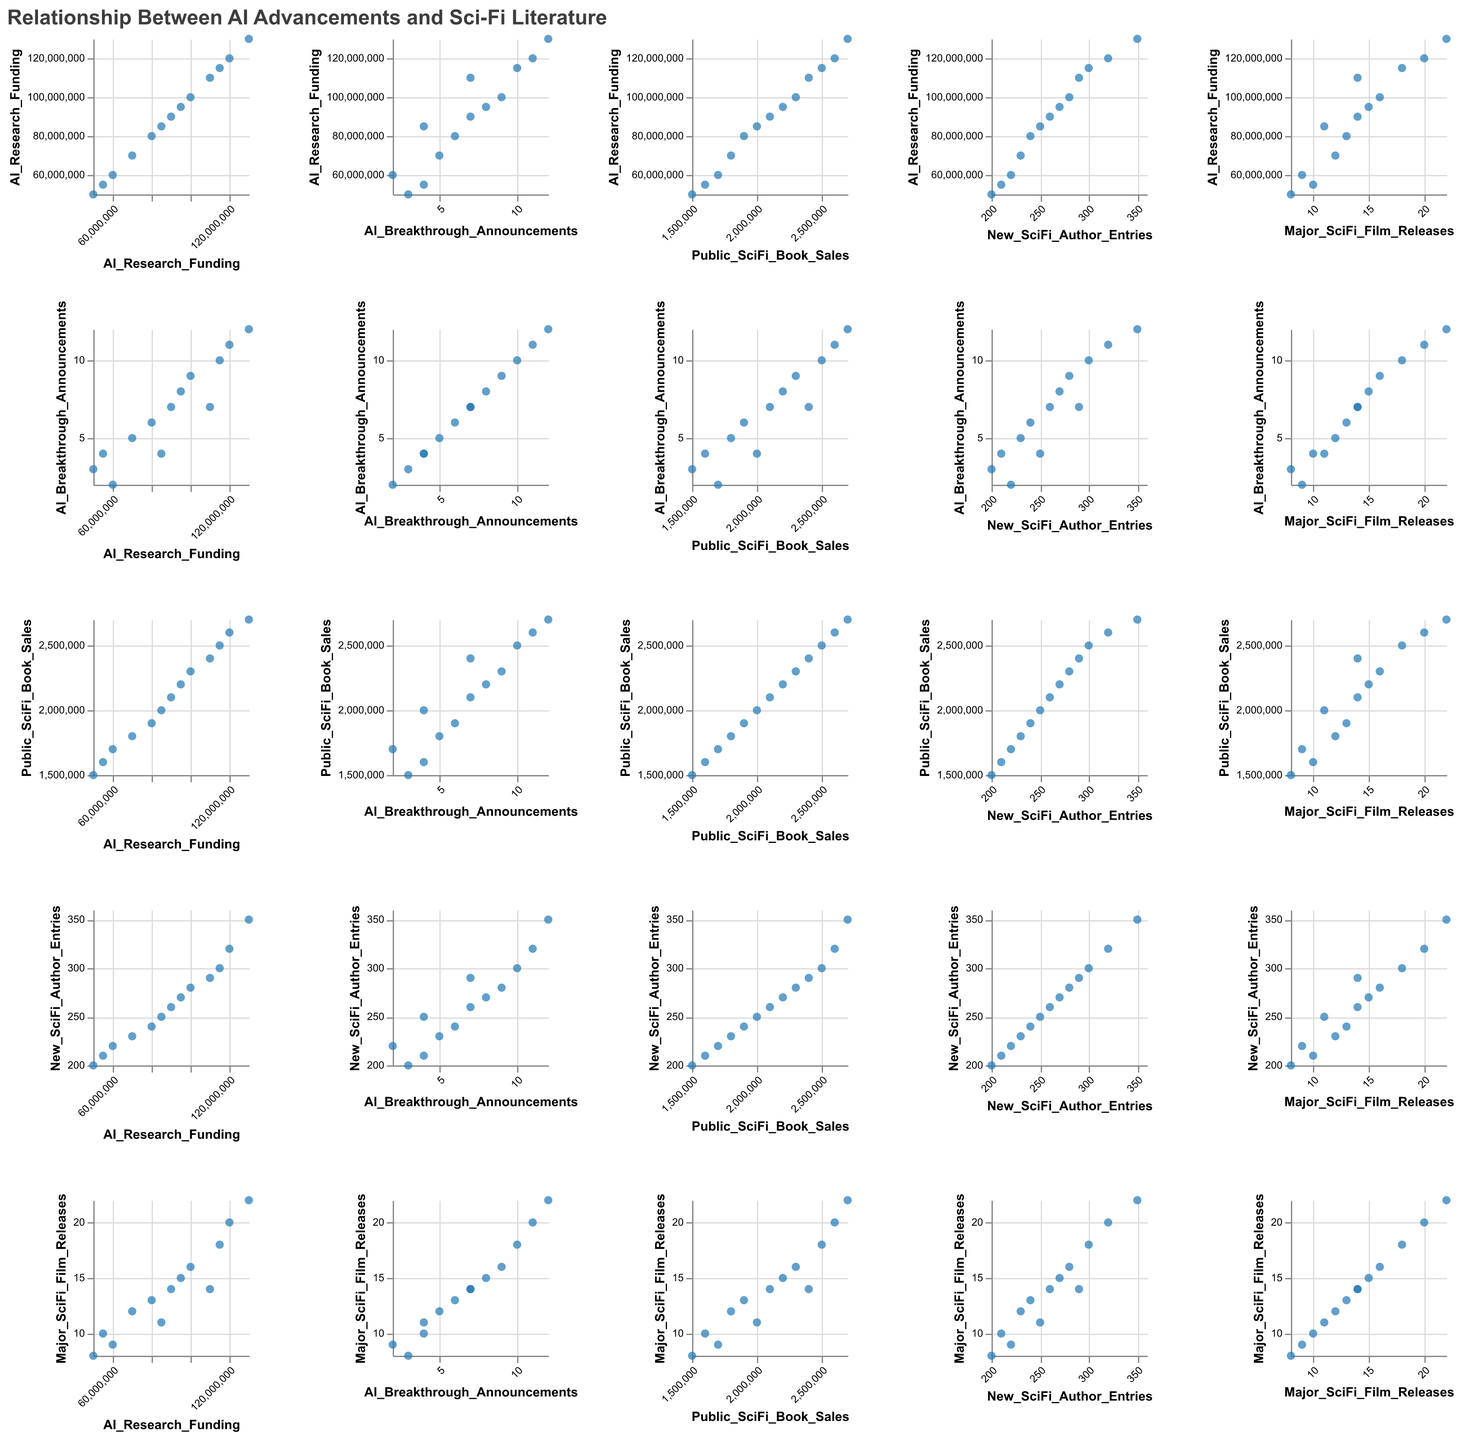What is the title of the figure? The title is given at the top of the figure, designed to provide an overview of what the figure represents. It is in bold and larger font size compared to other texts.
Answer: Relationship Between AI Advancements and Sci-Fi Literature Which variables are plotted in this Scatter Plot Matrix (SPLOM)? The variables are listed in both rows and columns of the SPLOM, indicating which data measures are being compared against each other. They are "AI_Research_Funding," "AI_Breakthrough_Announcements," "Public_SciFi_Book_Sales," "New_SciFi_Author_Entries," and "Major_SciFi_Film_Releases."
Answer: "AI_Research_Funding", "AI_Breakthrough_Announcements", "Public_SciFi_Book_Sales", "New_SciFi_Author_Entries", and "Major_SciFi_Film_Releases" How does "AI Research Funding" compare with "Public Sci-Fi Book Sales" over the years? Look at the scatter plot where "AI Research Funding" is on one axis and "Public Sci-Fi Book Sales" on the other axis. Generally, as "AI Research Funding" increases, "Public Sci-Fi Book Sales" also increase, indicating a positive relationship.
Answer: Positive relationship What is the trend in "New Sci-Fi Author Entries" with respect to "AI Breakthrough Announcements"? Check the scatter plot comparing "New Sci-Fi Author Entries" and "AI Breakthrough Announcements." More "AI Breakthrough Announcements" correlate with an increase in "New Sci-Fi Author Entries," showing a positive trend.
Answer: Positive trend Is there any notable relationship between "Major Sci-Fi Film Releases" and "AI Breakthrough Announcements"? Look for the scatter plot between "Major Sci-Fi Film Releases" and "AI Breakthrough Announcements." More announcements are associated with an increase in film releases, indicating a positive relationship.
Answer: Positive relationship Which variables appear to have the least strong relationship? Observe scatter plots with more scattered points with no clear trend lines. The scatter plot comparing "AI Research Funding" and "AI Breakthrough Announcements" appears to have the least strong relationship, as their increase does not seem directly proportional.
Answer: "AI Research Funding" and "AI Breakthrough Announcements" How many data points are there for each variable in the SPLOM? Each plot in the SPLOM represents data points over the years from 2010 to 2022. Counting the years from 2010 to 2022 gives 13 data points for each variable.
Answer: 13 Does "Public Sci-Fi Book Sales" show a clear trend when compared with "Major Sci-Fi Film Releases"? Compare the scatter plot of "Public Sci-Fi Book Sales" and "Major Sci-Fi Film Releases." A positive relationship is evident, as both variables tend to increase together.
Answer: Positive relationship 